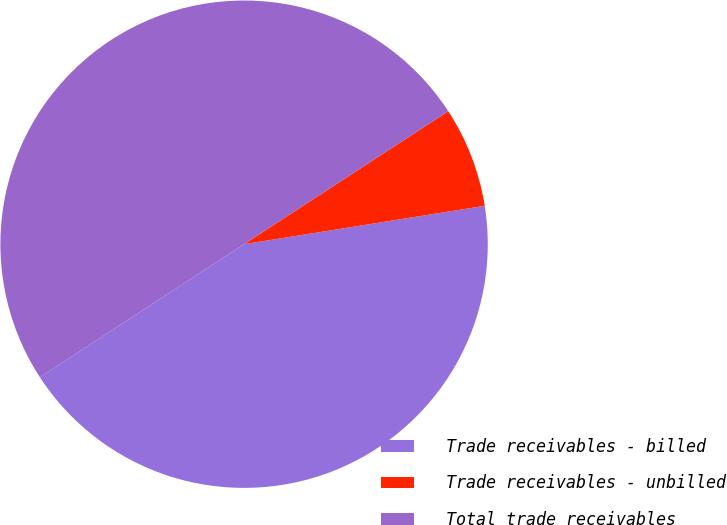Convert chart to OTSL. <chart><loc_0><loc_0><loc_500><loc_500><pie_chart><fcel>Trade receivables - billed<fcel>Trade receivables - unbilled<fcel>Total trade receivables<nl><fcel>43.33%<fcel>6.67%<fcel>50.0%<nl></chart> 